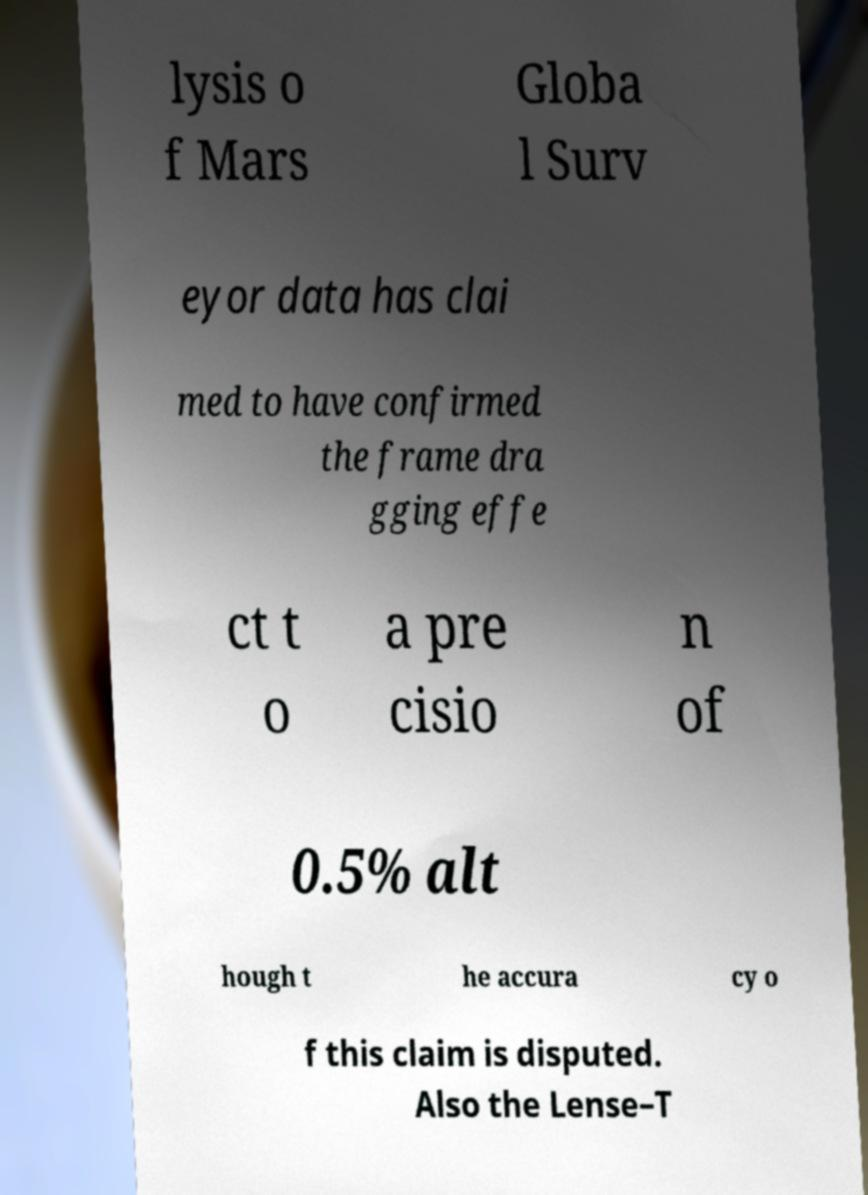Can you read and provide the text displayed in the image?This photo seems to have some interesting text. Can you extract and type it out for me? lysis o f Mars Globa l Surv eyor data has clai med to have confirmed the frame dra gging effe ct t o a pre cisio n of 0.5% alt hough t he accura cy o f this claim is disputed. Also the Lense–T 